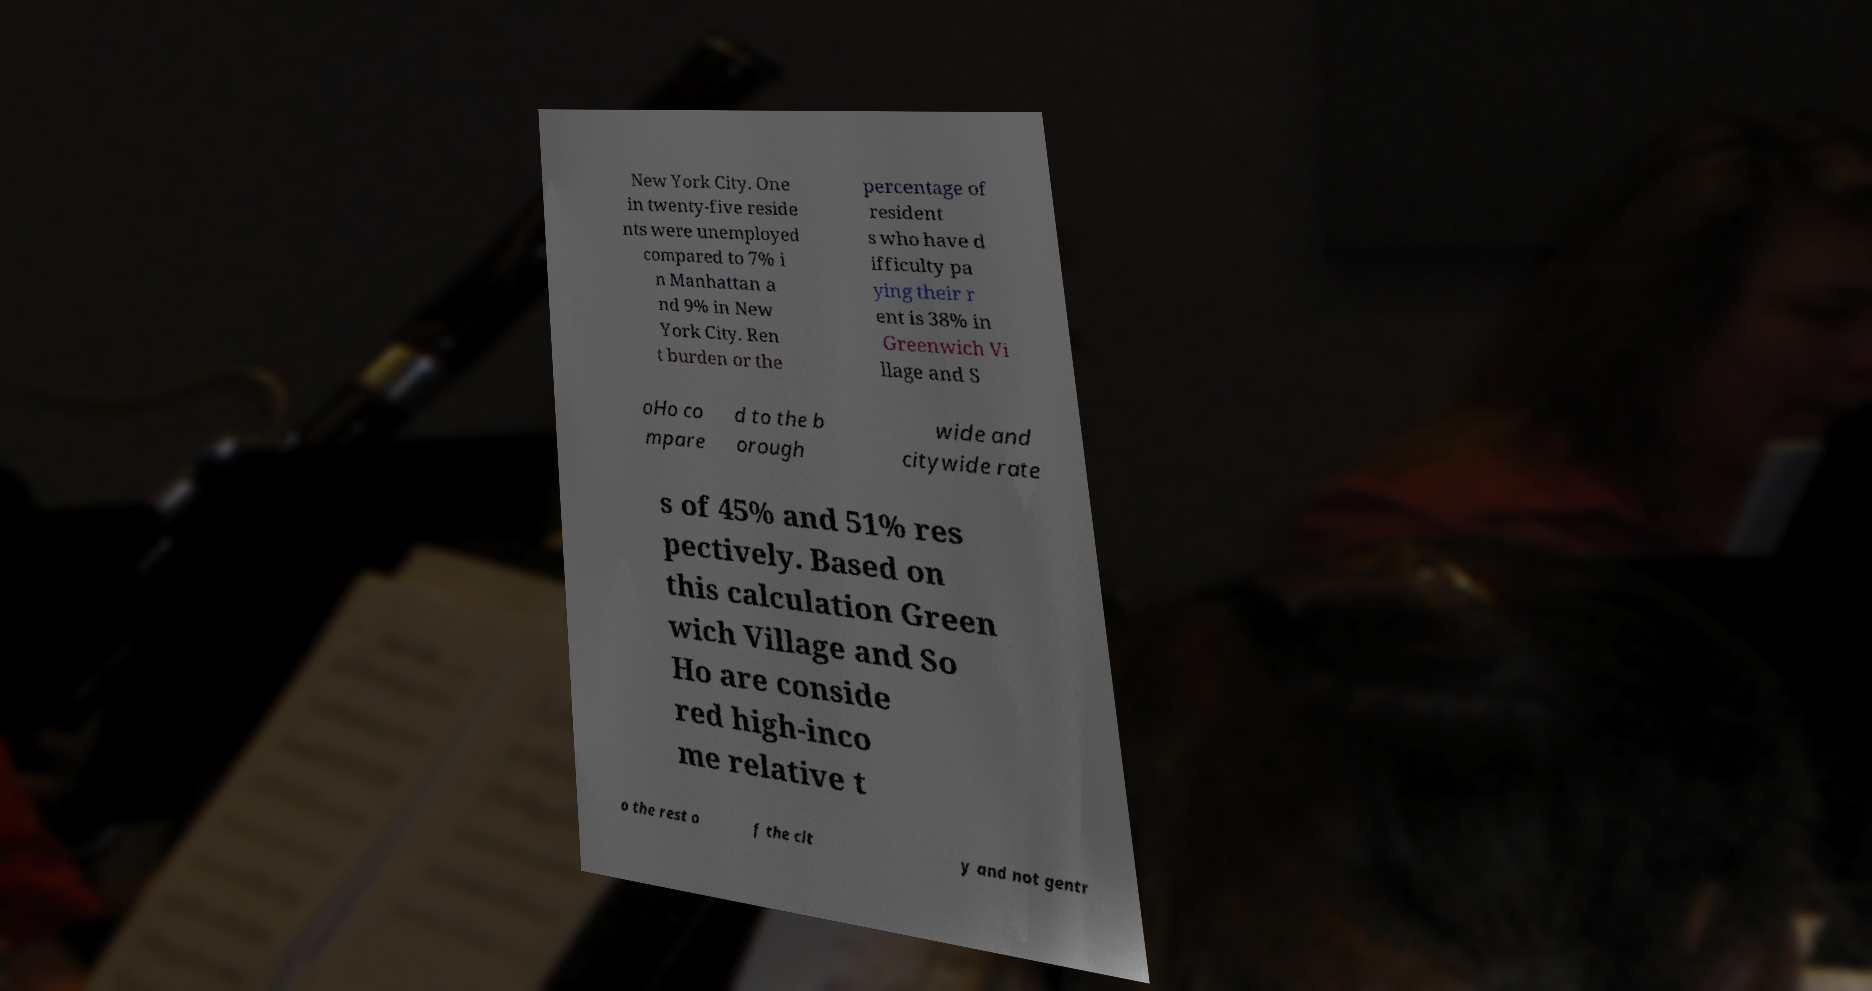Could you extract and type out the text from this image? New York City. One in twenty-five reside nts were unemployed compared to 7% i n Manhattan a nd 9% in New York City. Ren t burden or the percentage of resident s who have d ifficulty pa ying their r ent is 38% in Greenwich Vi llage and S oHo co mpare d to the b orough wide and citywide rate s of 45% and 51% res pectively. Based on this calculation Green wich Village and So Ho are conside red high-inco me relative t o the rest o f the cit y and not gentr 